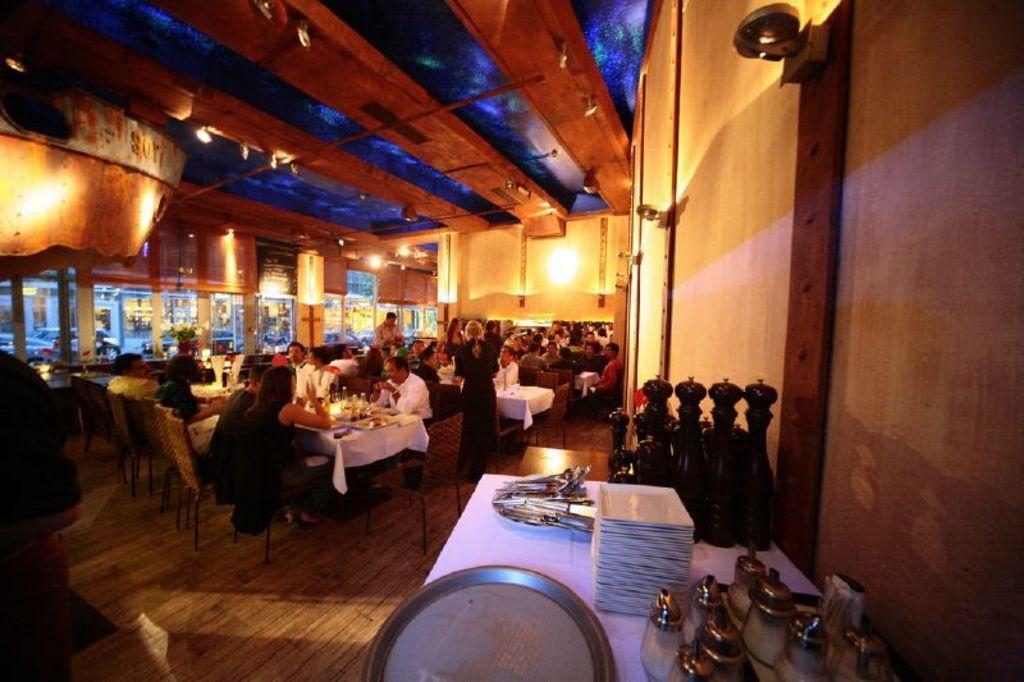In one or two sentences, can you explain what this image depicts? At the bottom of the image there is a table, on the table there are some plate and glasses. Behind the table there is a wall. In the middle of the image few people are sitting on chairs and few people are standing and there are some tables, on the tables there are some glasses, bottles and food items. Behind them there is a wall. At the top of the image there is roof. 